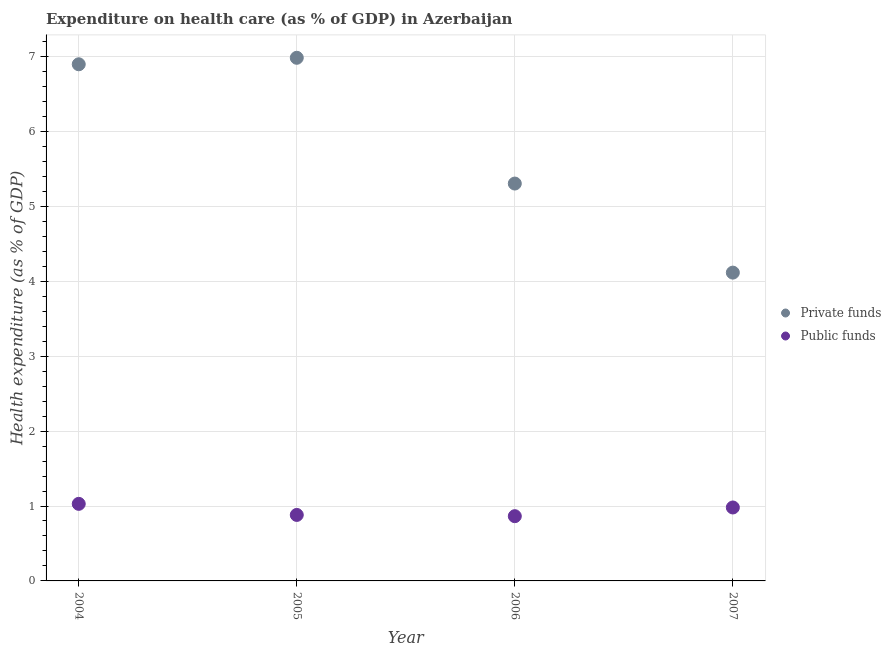How many different coloured dotlines are there?
Your answer should be compact. 2. Is the number of dotlines equal to the number of legend labels?
Keep it short and to the point. Yes. What is the amount of public funds spent in healthcare in 2005?
Ensure brevity in your answer.  0.88. Across all years, what is the maximum amount of private funds spent in healthcare?
Give a very brief answer. 6.98. Across all years, what is the minimum amount of private funds spent in healthcare?
Offer a very short reply. 4.11. In which year was the amount of private funds spent in healthcare maximum?
Your answer should be compact. 2005. What is the total amount of private funds spent in healthcare in the graph?
Keep it short and to the point. 23.3. What is the difference between the amount of public funds spent in healthcare in 2006 and that in 2007?
Provide a short and direct response. -0.12. What is the difference between the amount of public funds spent in healthcare in 2007 and the amount of private funds spent in healthcare in 2004?
Offer a very short reply. -5.92. What is the average amount of private funds spent in healthcare per year?
Your response must be concise. 5.82. In the year 2007, what is the difference between the amount of private funds spent in healthcare and amount of public funds spent in healthcare?
Offer a very short reply. 3.13. In how many years, is the amount of private funds spent in healthcare greater than 6.6 %?
Your response must be concise. 2. What is the ratio of the amount of public funds spent in healthcare in 2005 to that in 2006?
Make the answer very short. 1.02. What is the difference between the highest and the second highest amount of public funds spent in healthcare?
Provide a short and direct response. 0.05. What is the difference between the highest and the lowest amount of public funds spent in healthcare?
Offer a terse response. 0.16. In how many years, is the amount of private funds spent in healthcare greater than the average amount of private funds spent in healthcare taken over all years?
Your response must be concise. 2. Is the amount of public funds spent in healthcare strictly greater than the amount of private funds spent in healthcare over the years?
Your response must be concise. No. Is the amount of private funds spent in healthcare strictly less than the amount of public funds spent in healthcare over the years?
Make the answer very short. No. What is the difference between two consecutive major ticks on the Y-axis?
Your response must be concise. 1. Are the values on the major ticks of Y-axis written in scientific E-notation?
Provide a short and direct response. No. Does the graph contain any zero values?
Keep it short and to the point. No. What is the title of the graph?
Your answer should be compact. Expenditure on health care (as % of GDP) in Azerbaijan. What is the label or title of the Y-axis?
Provide a short and direct response. Health expenditure (as % of GDP). What is the Health expenditure (as % of GDP) of Private funds in 2004?
Your answer should be very brief. 6.9. What is the Health expenditure (as % of GDP) of Public funds in 2004?
Your answer should be compact. 1.03. What is the Health expenditure (as % of GDP) in Private funds in 2005?
Provide a short and direct response. 6.98. What is the Health expenditure (as % of GDP) in Public funds in 2005?
Make the answer very short. 0.88. What is the Health expenditure (as % of GDP) of Private funds in 2006?
Provide a succinct answer. 5.3. What is the Health expenditure (as % of GDP) in Public funds in 2006?
Provide a short and direct response. 0.86. What is the Health expenditure (as % of GDP) of Private funds in 2007?
Ensure brevity in your answer.  4.11. What is the Health expenditure (as % of GDP) in Public funds in 2007?
Keep it short and to the point. 0.98. Across all years, what is the maximum Health expenditure (as % of GDP) in Private funds?
Offer a terse response. 6.98. Across all years, what is the maximum Health expenditure (as % of GDP) of Public funds?
Give a very brief answer. 1.03. Across all years, what is the minimum Health expenditure (as % of GDP) of Private funds?
Make the answer very short. 4.11. Across all years, what is the minimum Health expenditure (as % of GDP) in Public funds?
Your response must be concise. 0.86. What is the total Health expenditure (as % of GDP) in Private funds in the graph?
Your answer should be very brief. 23.3. What is the total Health expenditure (as % of GDP) of Public funds in the graph?
Offer a very short reply. 3.75. What is the difference between the Health expenditure (as % of GDP) of Private funds in 2004 and that in 2005?
Offer a terse response. -0.09. What is the difference between the Health expenditure (as % of GDP) of Public funds in 2004 and that in 2005?
Provide a succinct answer. 0.15. What is the difference between the Health expenditure (as % of GDP) of Private funds in 2004 and that in 2006?
Your answer should be very brief. 1.59. What is the difference between the Health expenditure (as % of GDP) of Public funds in 2004 and that in 2006?
Give a very brief answer. 0.16. What is the difference between the Health expenditure (as % of GDP) in Private funds in 2004 and that in 2007?
Keep it short and to the point. 2.78. What is the difference between the Health expenditure (as % of GDP) of Public funds in 2004 and that in 2007?
Give a very brief answer. 0.05. What is the difference between the Health expenditure (as % of GDP) of Private funds in 2005 and that in 2006?
Your answer should be compact. 1.68. What is the difference between the Health expenditure (as % of GDP) in Public funds in 2005 and that in 2006?
Your answer should be compact. 0.02. What is the difference between the Health expenditure (as % of GDP) of Private funds in 2005 and that in 2007?
Offer a very short reply. 2.87. What is the difference between the Health expenditure (as % of GDP) of Public funds in 2005 and that in 2007?
Your response must be concise. -0.1. What is the difference between the Health expenditure (as % of GDP) in Private funds in 2006 and that in 2007?
Offer a very short reply. 1.19. What is the difference between the Health expenditure (as % of GDP) of Public funds in 2006 and that in 2007?
Ensure brevity in your answer.  -0.12. What is the difference between the Health expenditure (as % of GDP) of Private funds in 2004 and the Health expenditure (as % of GDP) of Public funds in 2005?
Make the answer very short. 6.01. What is the difference between the Health expenditure (as % of GDP) of Private funds in 2004 and the Health expenditure (as % of GDP) of Public funds in 2006?
Provide a succinct answer. 6.03. What is the difference between the Health expenditure (as % of GDP) of Private funds in 2004 and the Health expenditure (as % of GDP) of Public funds in 2007?
Your answer should be compact. 5.92. What is the difference between the Health expenditure (as % of GDP) of Private funds in 2005 and the Health expenditure (as % of GDP) of Public funds in 2006?
Provide a short and direct response. 6.12. What is the difference between the Health expenditure (as % of GDP) of Private funds in 2005 and the Health expenditure (as % of GDP) of Public funds in 2007?
Your response must be concise. 6. What is the difference between the Health expenditure (as % of GDP) of Private funds in 2006 and the Health expenditure (as % of GDP) of Public funds in 2007?
Keep it short and to the point. 4.32. What is the average Health expenditure (as % of GDP) in Private funds per year?
Provide a succinct answer. 5.82. What is the average Health expenditure (as % of GDP) in Public funds per year?
Offer a terse response. 0.94. In the year 2004, what is the difference between the Health expenditure (as % of GDP) in Private funds and Health expenditure (as % of GDP) in Public funds?
Ensure brevity in your answer.  5.87. In the year 2005, what is the difference between the Health expenditure (as % of GDP) of Private funds and Health expenditure (as % of GDP) of Public funds?
Offer a very short reply. 6.1. In the year 2006, what is the difference between the Health expenditure (as % of GDP) of Private funds and Health expenditure (as % of GDP) of Public funds?
Offer a terse response. 4.44. In the year 2007, what is the difference between the Health expenditure (as % of GDP) of Private funds and Health expenditure (as % of GDP) of Public funds?
Your answer should be compact. 3.13. What is the ratio of the Health expenditure (as % of GDP) of Private funds in 2004 to that in 2005?
Keep it short and to the point. 0.99. What is the ratio of the Health expenditure (as % of GDP) in Public funds in 2004 to that in 2005?
Keep it short and to the point. 1.17. What is the ratio of the Health expenditure (as % of GDP) in Private funds in 2004 to that in 2006?
Keep it short and to the point. 1.3. What is the ratio of the Health expenditure (as % of GDP) of Public funds in 2004 to that in 2006?
Your response must be concise. 1.19. What is the ratio of the Health expenditure (as % of GDP) of Private funds in 2004 to that in 2007?
Provide a short and direct response. 1.68. What is the ratio of the Health expenditure (as % of GDP) of Public funds in 2004 to that in 2007?
Make the answer very short. 1.05. What is the ratio of the Health expenditure (as % of GDP) in Private funds in 2005 to that in 2006?
Your response must be concise. 1.32. What is the ratio of the Health expenditure (as % of GDP) of Public funds in 2005 to that in 2006?
Provide a succinct answer. 1.02. What is the ratio of the Health expenditure (as % of GDP) of Private funds in 2005 to that in 2007?
Your answer should be very brief. 1.7. What is the ratio of the Health expenditure (as % of GDP) of Public funds in 2005 to that in 2007?
Provide a succinct answer. 0.9. What is the ratio of the Health expenditure (as % of GDP) of Private funds in 2006 to that in 2007?
Ensure brevity in your answer.  1.29. What is the ratio of the Health expenditure (as % of GDP) in Public funds in 2006 to that in 2007?
Give a very brief answer. 0.88. What is the difference between the highest and the second highest Health expenditure (as % of GDP) in Private funds?
Provide a short and direct response. 0.09. What is the difference between the highest and the second highest Health expenditure (as % of GDP) in Public funds?
Your answer should be very brief. 0.05. What is the difference between the highest and the lowest Health expenditure (as % of GDP) of Private funds?
Your response must be concise. 2.87. What is the difference between the highest and the lowest Health expenditure (as % of GDP) in Public funds?
Ensure brevity in your answer.  0.16. 